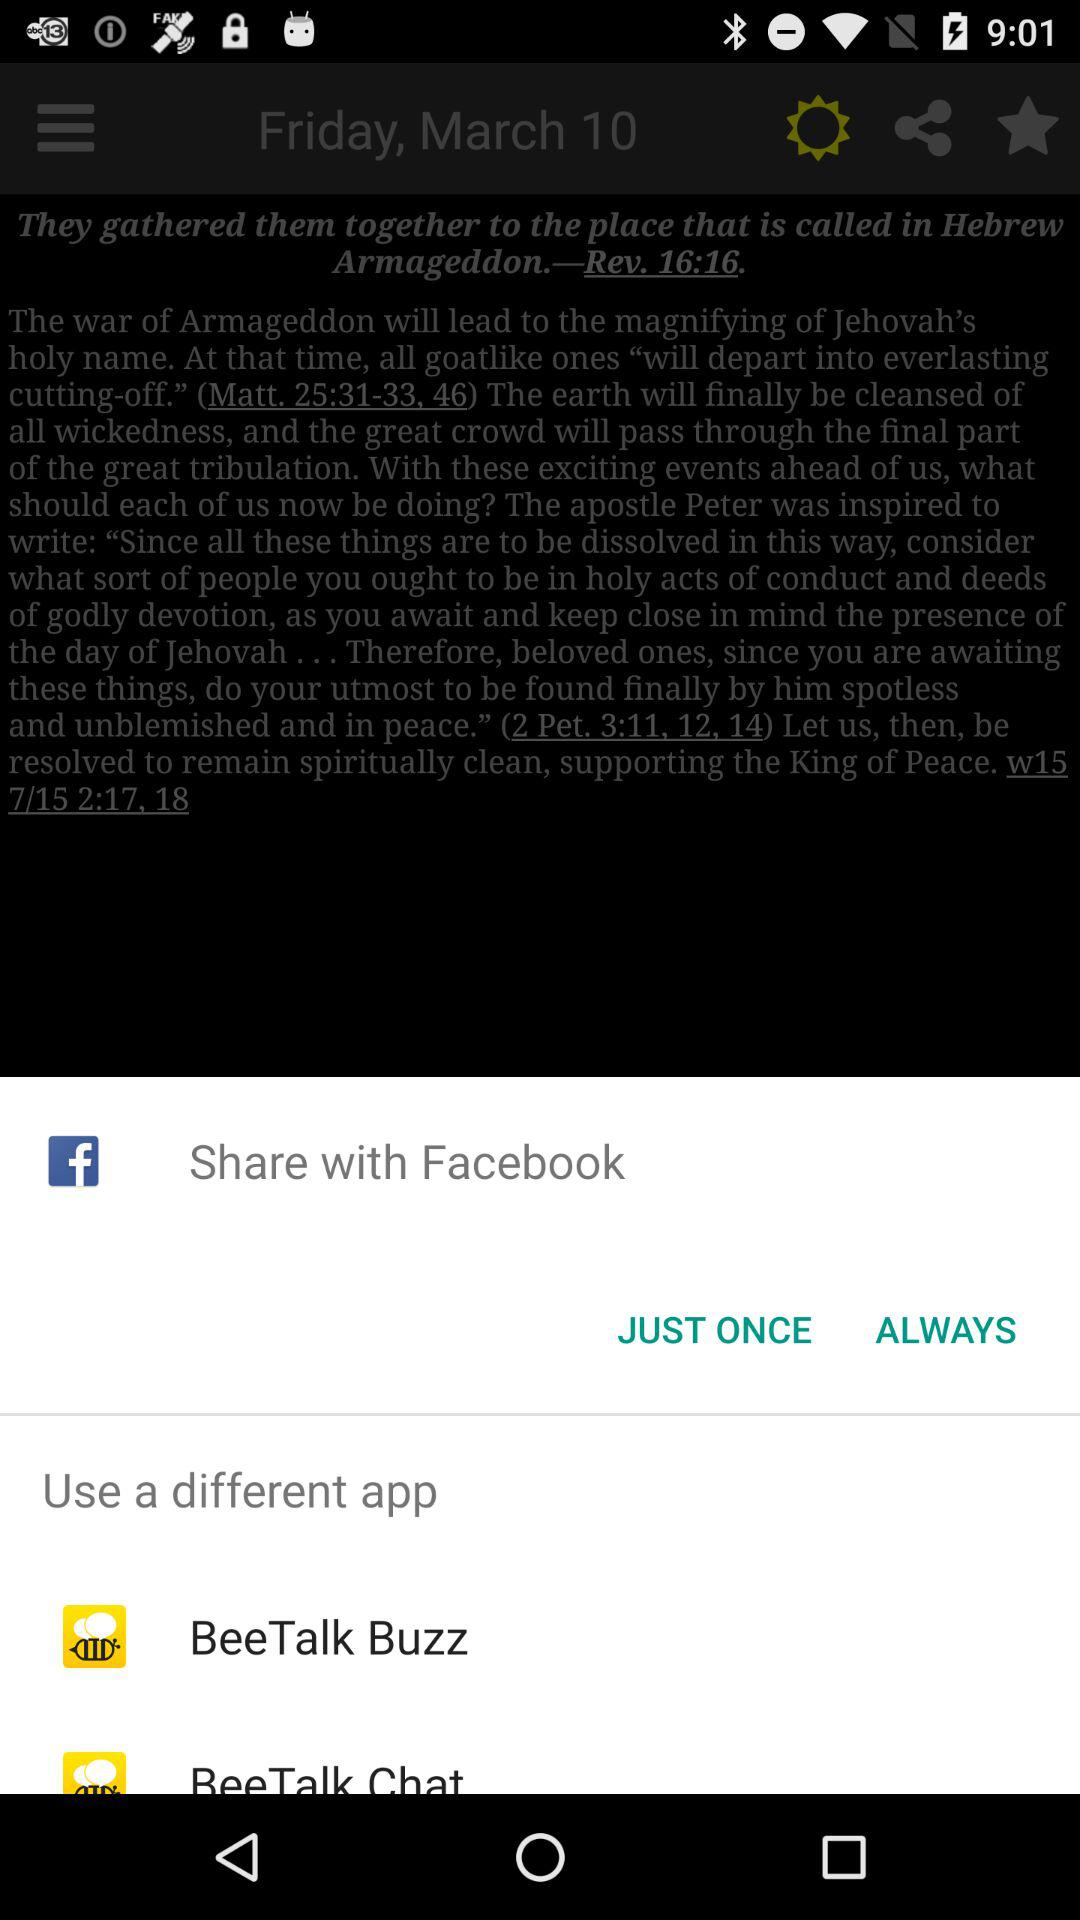Which applications can we use to share? The applications are "Facebook" and "BeeTalk Buzz". 